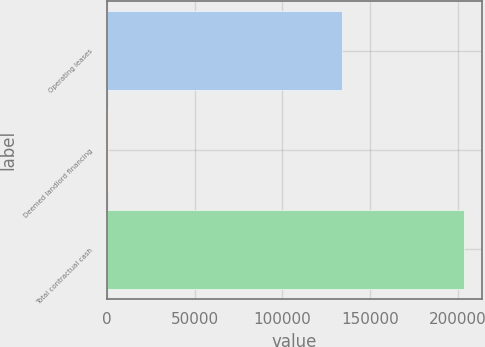Convert chart. <chart><loc_0><loc_0><loc_500><loc_500><bar_chart><fcel>Operating leases<fcel>Deemed landlord financing<fcel>Total contractual cash<nl><fcel>133813<fcel>394<fcel>203577<nl></chart> 